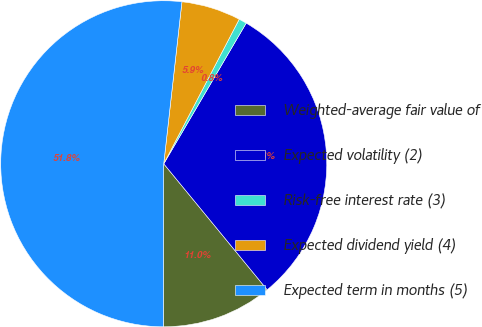Convert chart. <chart><loc_0><loc_0><loc_500><loc_500><pie_chart><fcel>Weighted-average fair value of<fcel>Expected volatility (2)<fcel>Risk-free interest rate (3)<fcel>Expected dividend yield (4)<fcel>Expected term in months (5)<nl><fcel>10.97%<fcel>30.62%<fcel>0.78%<fcel>5.88%<fcel>51.76%<nl></chart> 